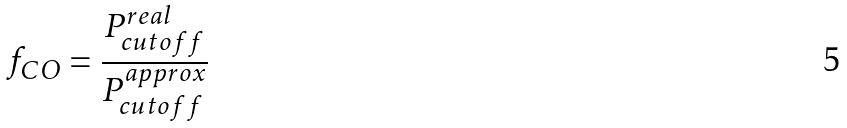Convert formula to latex. <formula><loc_0><loc_0><loc_500><loc_500>f _ { C O } = \frac { P _ { c u t o f f } ^ { r e a l } } { P _ { c u t o f f } ^ { a p p r o x } }</formula> 